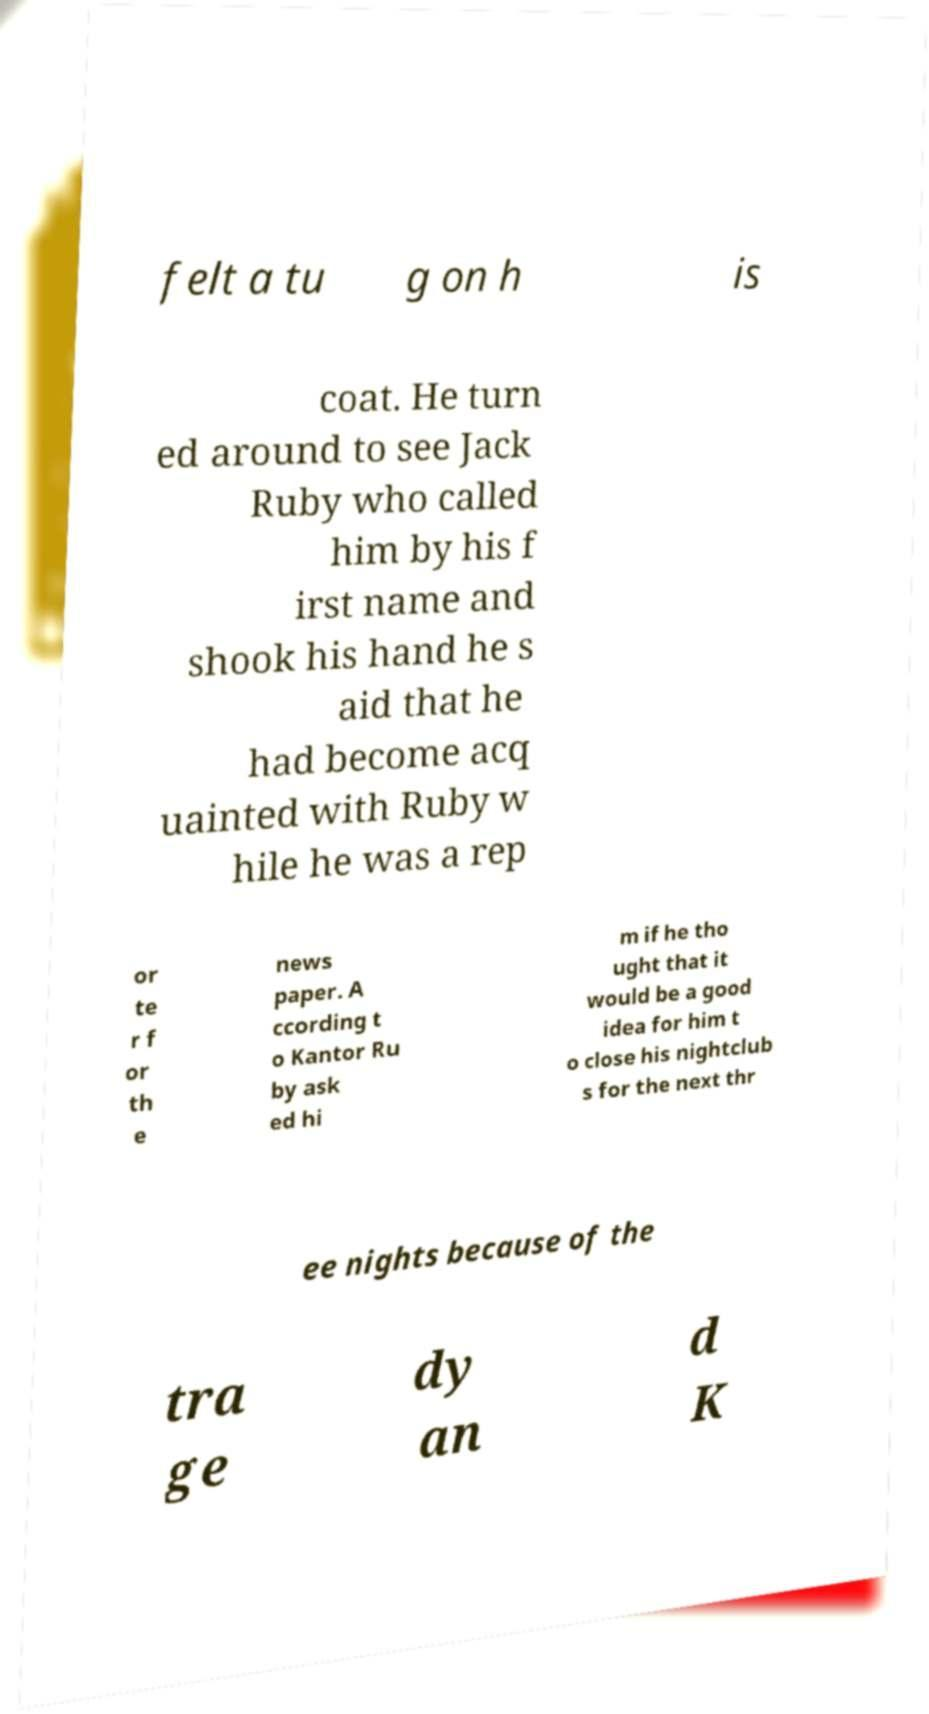Could you extract and type out the text from this image? felt a tu g on h is coat. He turn ed around to see Jack Ruby who called him by his f irst name and shook his hand he s aid that he had become acq uainted with Ruby w hile he was a rep or te r f or th e news paper. A ccording t o Kantor Ru by ask ed hi m if he tho ught that it would be a good idea for him t o close his nightclub s for the next thr ee nights because of the tra ge dy an d K 